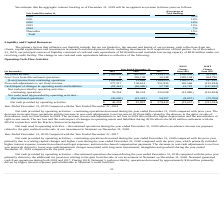According to Allscripts Healthcare Solutions's financial document, What led to decrease in income from operations and the increase in non-cash adjustments to net income in 2019? partially related to the absence in the gains on sale of divestitures, such as OneContent in 2018.. The document states: "ease in non-cash adjustments to net income in 2019 partially related to the absence in the gains on sale of divestitures, such as OneContent in 2018. ..." Also, What was the Net cash provided by operating activities in 2019? According to the financial document, $ 46,254 (in thousands). The relevant text states: "Net cash provided by operating activities $ 46,254 $ 67,891 $ 279,415 $ (21,637) $ (211,524)..." Also, What led to decreased Net cash provided by operating activities – continuing operations during the year ended December 31, 2018 compared to the prior year? due to working capital changes and higher costs during the year ended December 31, 2018 compared with the prior year, which primarily included higher interest expense, transaction-related and legal expenses, and incentive-based compensation payments.. The document states: "primarily due to working capital changes and higher costs during the year ended December 31, 2018 compared with the prior year, which primarily includ..." Also, can you calculate: What is the change in Net (loss) income between 2019 and 2017? Based on the calculation: -182,602-(-154,175), the result is -28427 (in thousands). This is based on the information: "Net (loss) income $ (182,602) $ 407,807 $ (154,175) $ (590,409) $ 561,982 Net (loss) income $ (182,602) $ 407,807 $ (154,175) $ (590,409) $ 561,982..." The key data points involved are: 154,175, 182,602. Also, can you calculate: What is the change in (Loss) income from continuing operations between 2019 and 2017? Based on the calculation: -182,602-(-184,523), the result is 1921 (in thousands). This is based on the information: "come from continuing operations (182,602) 12,669 (184,523) (195,271) 197,192 (Loss) income from continuing operations (182,602) 12,669 (184,523) (195,271) 197,192..." The key data points involved are: 182,602, 184,523. Also, can you calculate: What is the change in Non-cash adjustments to net (loss) income between 2019 and 2017? Based on the calculation: 277,217-351,835, the result is -74618 (in thousands). This is based on the information: "adjustments to net (loss) income 277,217 136,651 351,835 140,566 (215,184) Non-cash adjustments to net (loss) income 277,217 136,651 351,835 140,566 (215,184)..." The key data points involved are: 277,217, 351,835. 